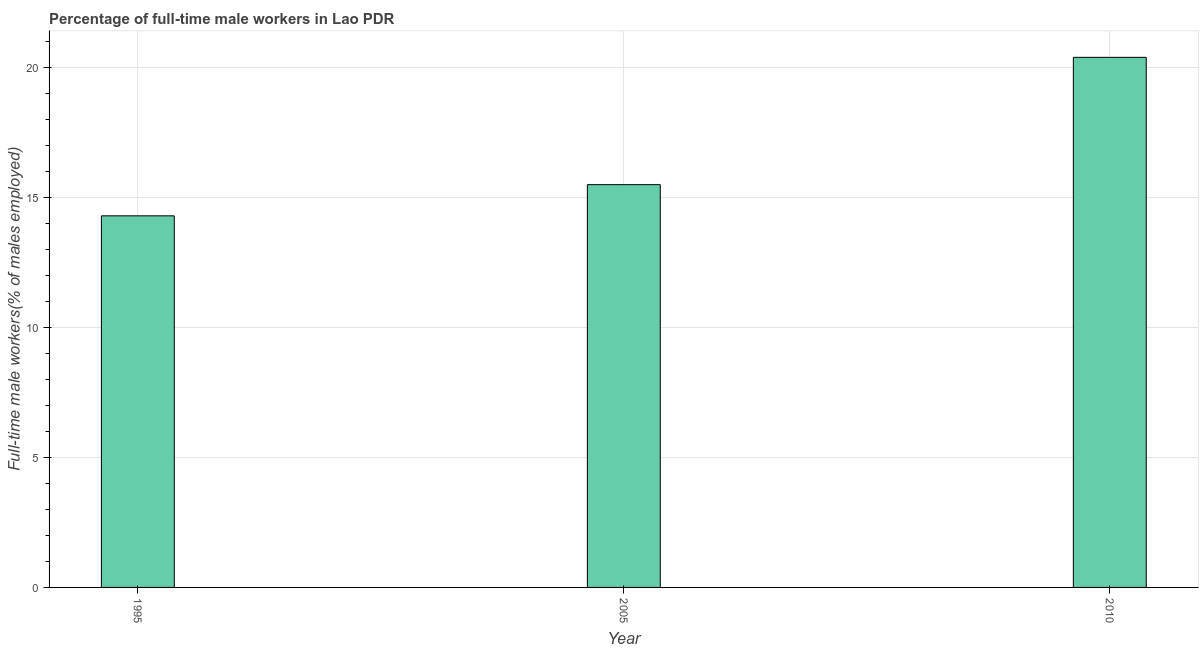Does the graph contain any zero values?
Provide a short and direct response. No. What is the title of the graph?
Your answer should be very brief. Percentage of full-time male workers in Lao PDR. What is the label or title of the X-axis?
Keep it short and to the point. Year. What is the label or title of the Y-axis?
Provide a short and direct response. Full-time male workers(% of males employed). What is the percentage of full-time male workers in 1995?
Your answer should be compact. 14.3. Across all years, what is the maximum percentage of full-time male workers?
Provide a short and direct response. 20.4. Across all years, what is the minimum percentage of full-time male workers?
Provide a succinct answer. 14.3. What is the sum of the percentage of full-time male workers?
Give a very brief answer. 50.2. What is the difference between the percentage of full-time male workers in 1995 and 2010?
Your answer should be very brief. -6.1. What is the average percentage of full-time male workers per year?
Your response must be concise. 16.73. In how many years, is the percentage of full-time male workers greater than 11 %?
Your response must be concise. 3. Do a majority of the years between 2010 and 2005 (inclusive) have percentage of full-time male workers greater than 12 %?
Make the answer very short. No. What is the ratio of the percentage of full-time male workers in 1995 to that in 2005?
Offer a terse response. 0.92. What is the difference between the highest and the lowest percentage of full-time male workers?
Provide a short and direct response. 6.1. How many bars are there?
Keep it short and to the point. 3. Are the values on the major ticks of Y-axis written in scientific E-notation?
Offer a terse response. No. What is the Full-time male workers(% of males employed) in 1995?
Your answer should be very brief. 14.3. What is the Full-time male workers(% of males employed) of 2005?
Give a very brief answer. 15.5. What is the Full-time male workers(% of males employed) of 2010?
Your response must be concise. 20.4. What is the difference between the Full-time male workers(% of males employed) in 1995 and 2010?
Give a very brief answer. -6.1. What is the difference between the Full-time male workers(% of males employed) in 2005 and 2010?
Give a very brief answer. -4.9. What is the ratio of the Full-time male workers(% of males employed) in 1995 to that in 2005?
Your answer should be very brief. 0.92. What is the ratio of the Full-time male workers(% of males employed) in 1995 to that in 2010?
Provide a succinct answer. 0.7. What is the ratio of the Full-time male workers(% of males employed) in 2005 to that in 2010?
Provide a short and direct response. 0.76. 